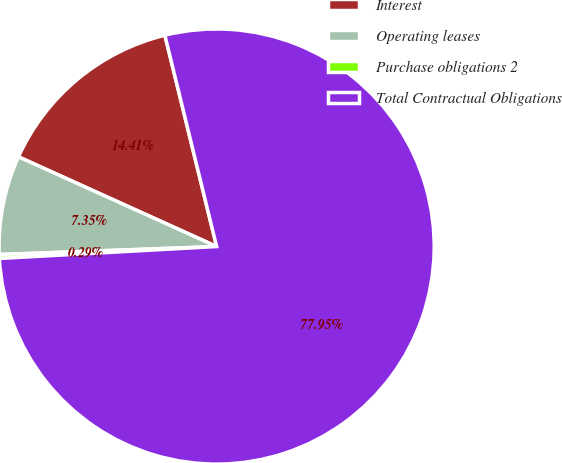<chart> <loc_0><loc_0><loc_500><loc_500><pie_chart><fcel>Interest<fcel>Operating leases<fcel>Purchase obligations 2<fcel>Total Contractual Obligations<nl><fcel>14.41%<fcel>7.35%<fcel>0.29%<fcel>77.95%<nl></chart> 